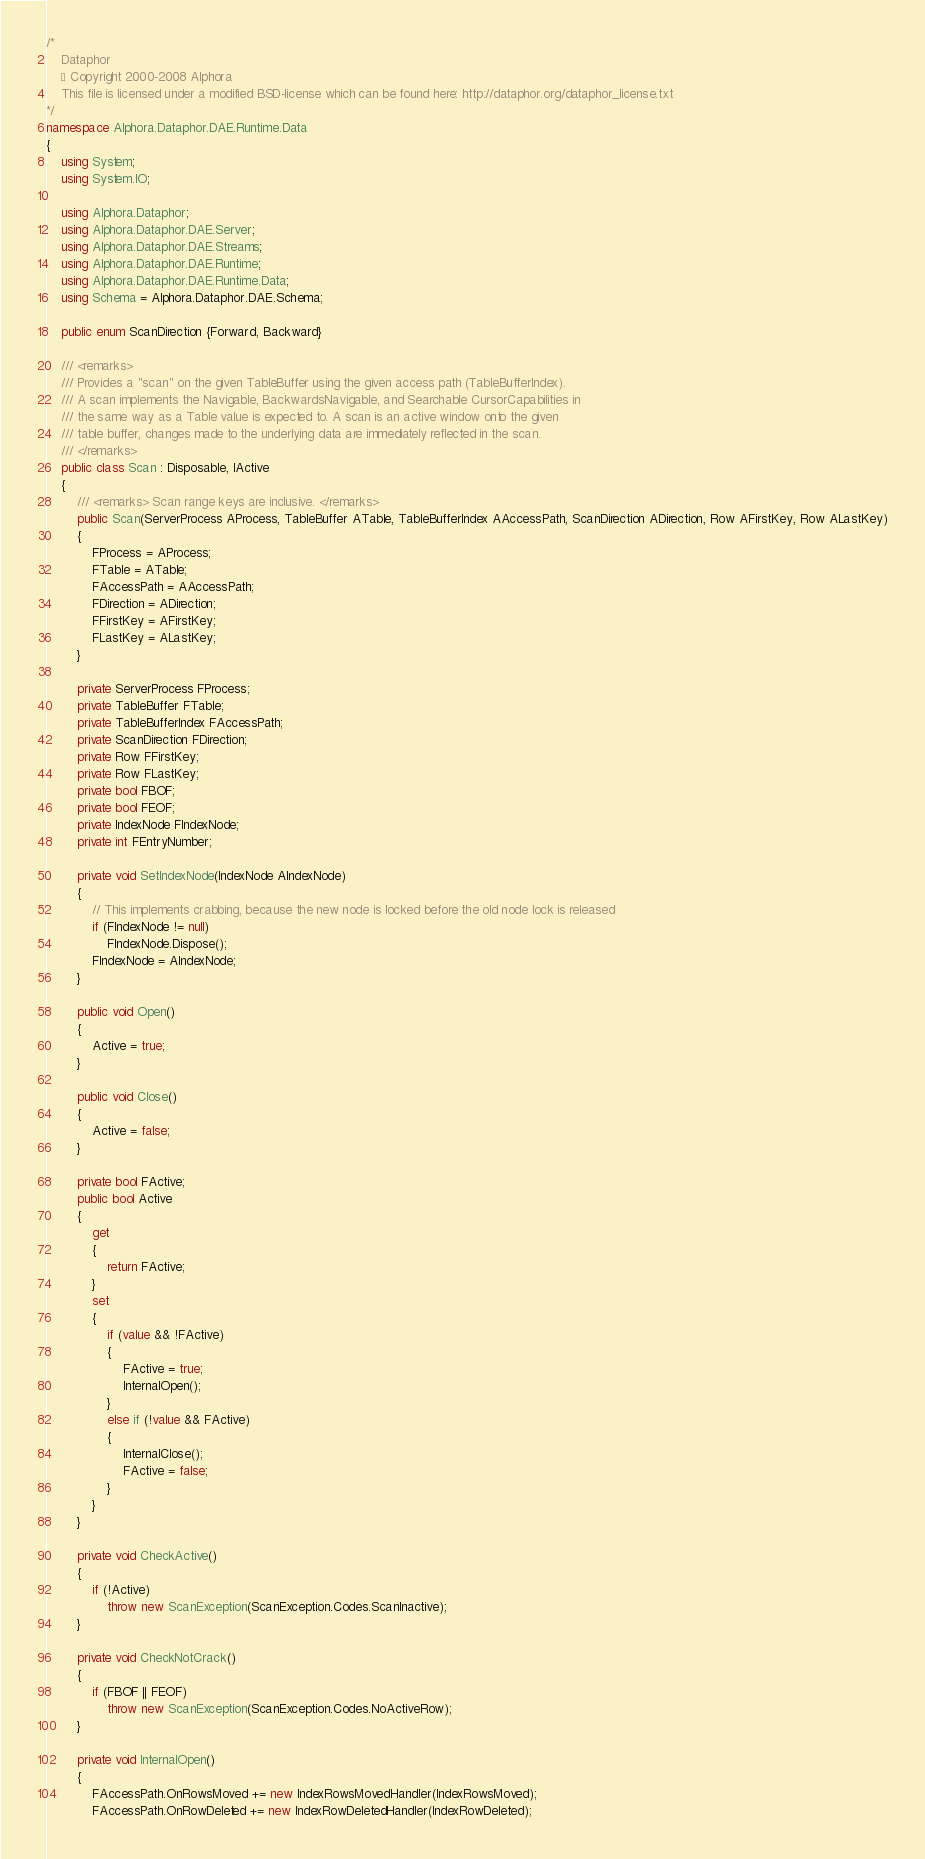Convert code to text. <code><loc_0><loc_0><loc_500><loc_500><_C#_>/*
	Dataphor
	© Copyright 2000-2008 Alphora
	This file is licensed under a modified BSD-license which can be found here: http://dataphor.org/dataphor_license.txt
*/
namespace Alphora.Dataphor.DAE.Runtime.Data
{
	using System;
	using System.IO;

	using Alphora.Dataphor;
	using Alphora.Dataphor.DAE.Server;
	using Alphora.Dataphor.DAE.Streams;
	using Alphora.Dataphor.DAE.Runtime;
	using Alphora.Dataphor.DAE.Runtime.Data;
	using Schema = Alphora.Dataphor.DAE.Schema;
	
	public enum ScanDirection {Forward, Backward}
	    
	///	<remarks>
	/// Provides a "scan" on the given TableBuffer using the given access path (TableBufferIndex).
	/// A scan implements the Navigable, BackwardsNavigable, and Searchable CursorCapabilities in
	/// the same way as a Table value is expected to. A scan is an active window onto the given
	/// table buffer, changes made to the underlying data are immediately reflected in the scan.
	/// </remarks>
	public class Scan : Disposable, IActive
	{
		/// <remarks> Scan range keys are inclusive. </remarks>		
		public Scan(ServerProcess AProcess, TableBuffer ATable, TableBufferIndex AAccessPath, ScanDirection ADirection, Row AFirstKey, Row ALastKey)
		{
			FProcess = AProcess;
			FTable = ATable;
			FAccessPath = AAccessPath;
			FDirection = ADirection;
			FFirstKey = AFirstKey;
			FLastKey = ALastKey;
		}

		private ServerProcess FProcess;
		private TableBuffer FTable;
		private TableBufferIndex FAccessPath;
		private ScanDirection FDirection;
		private Row FFirstKey;
		private Row FLastKey;
		private bool FBOF;
		private bool FEOF;
		private IndexNode FIndexNode;
		private int FEntryNumber;

		private void SetIndexNode(IndexNode AIndexNode)
		{
			// This implements crabbing, because the new node is locked before the old node lock is released
			if (FIndexNode != null)
				FIndexNode.Dispose();
			FIndexNode = AIndexNode;
		}
		
		public void Open()
		{
			Active = true;
		}
		
		public void Close()
		{
			Active = false;
		}
		
		private bool FActive;
		public bool Active
		{
			get
			{
				return FActive;
			}
			set
			{
				if (value && !FActive)
				{
					FActive = true;
					InternalOpen();
				}
				else if (!value && FActive)
				{
					InternalClose();
					FActive = false;
				}
			}
		}
		
		private void CheckActive()
		{
			if (!Active)
				throw new ScanException(ScanException.Codes.ScanInactive);
		}
		
		private void CheckNotCrack()
		{
			if (FBOF || FEOF)
				throw new ScanException(ScanException.Codes.NoActiveRow);
		}
		
		private void InternalOpen()
		{
			FAccessPath.OnRowsMoved += new IndexRowsMovedHandler(IndexRowsMoved);
			FAccessPath.OnRowDeleted += new IndexRowDeletedHandler(IndexRowDeleted);</code> 